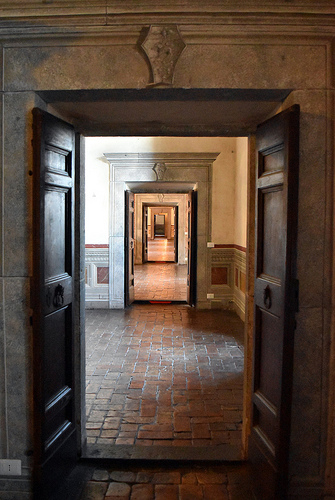<image>
Can you confirm if the ornament is above the door? Yes. The ornament is positioned above the door in the vertical space, higher up in the scene. 